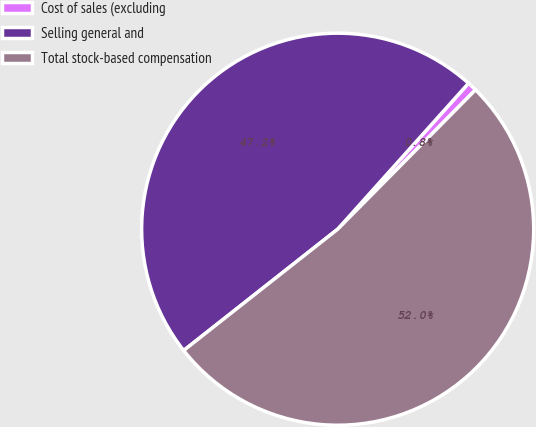Convert chart to OTSL. <chart><loc_0><loc_0><loc_500><loc_500><pie_chart><fcel>Cost of sales (excluding<fcel>Selling general and<fcel>Total stock-based compensation<nl><fcel>0.78%<fcel>47.25%<fcel>51.97%<nl></chart> 